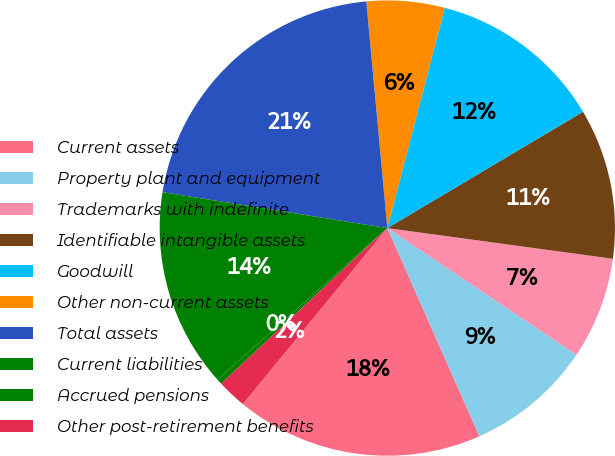<chart> <loc_0><loc_0><loc_500><loc_500><pie_chart><fcel>Current assets<fcel>Property plant and equipment<fcel>Trademarks with indefinite<fcel>Identifiable intangible assets<fcel>Goodwill<fcel>Other non-current assets<fcel>Total assets<fcel>Current liabilities<fcel>Accrued pensions<fcel>Other post-retirement benefits<nl><fcel>17.57%<fcel>8.97%<fcel>7.25%<fcel>10.69%<fcel>12.41%<fcel>5.53%<fcel>21.01%<fcel>14.13%<fcel>0.37%<fcel>2.09%<nl></chart> 